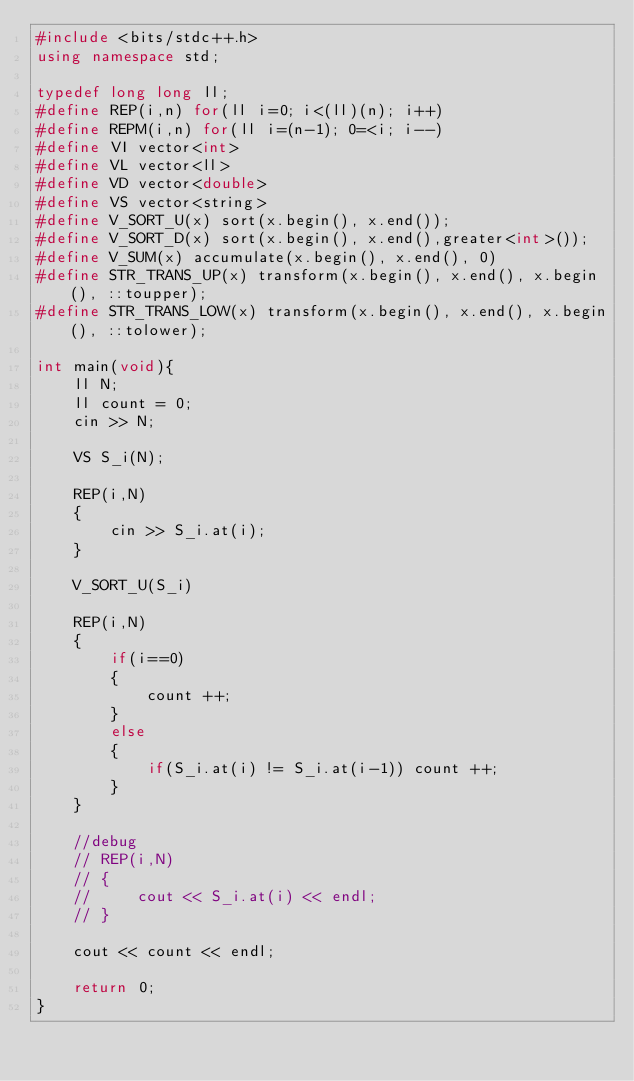<code> <loc_0><loc_0><loc_500><loc_500><_C++_>#include <bits/stdc++.h>
using namespace std;

typedef long long ll;
#define REP(i,n) for(ll i=0; i<(ll)(n); i++)
#define REPM(i,n) for(ll i=(n-1); 0=<i; i--)
#define VI vector<int>
#define VL vector<ll>
#define VD vector<double>
#define VS vector<string>
#define V_SORT_U(x) sort(x.begin(), x.end());
#define V_SORT_D(x) sort(x.begin(), x.end(),greater<int>());
#define V_SUM(x) accumulate(x.begin(), x.end(), 0)
#define STR_TRANS_UP(x) transform(x.begin(), x.end(), x.begin(), ::toupper);
#define STR_TRANS_LOW(x) transform(x.begin(), x.end(), x.begin(), ::tolower);

int main(void){
    ll N;
    ll count = 0;
    cin >> N;

    VS S_i(N);

    REP(i,N)
    {
        cin >> S_i.at(i);
    }

    V_SORT_U(S_i)

    REP(i,N)
    {
        if(i==0)
        {
            count ++;
        }
        else
        {
            if(S_i.at(i) != S_i.at(i-1)) count ++;
        }
    }

    //debug
    // REP(i,N)
    // {
    //     cout << S_i.at(i) << endl;
    // }
    
    cout << count << endl;

    return 0;
}</code> 